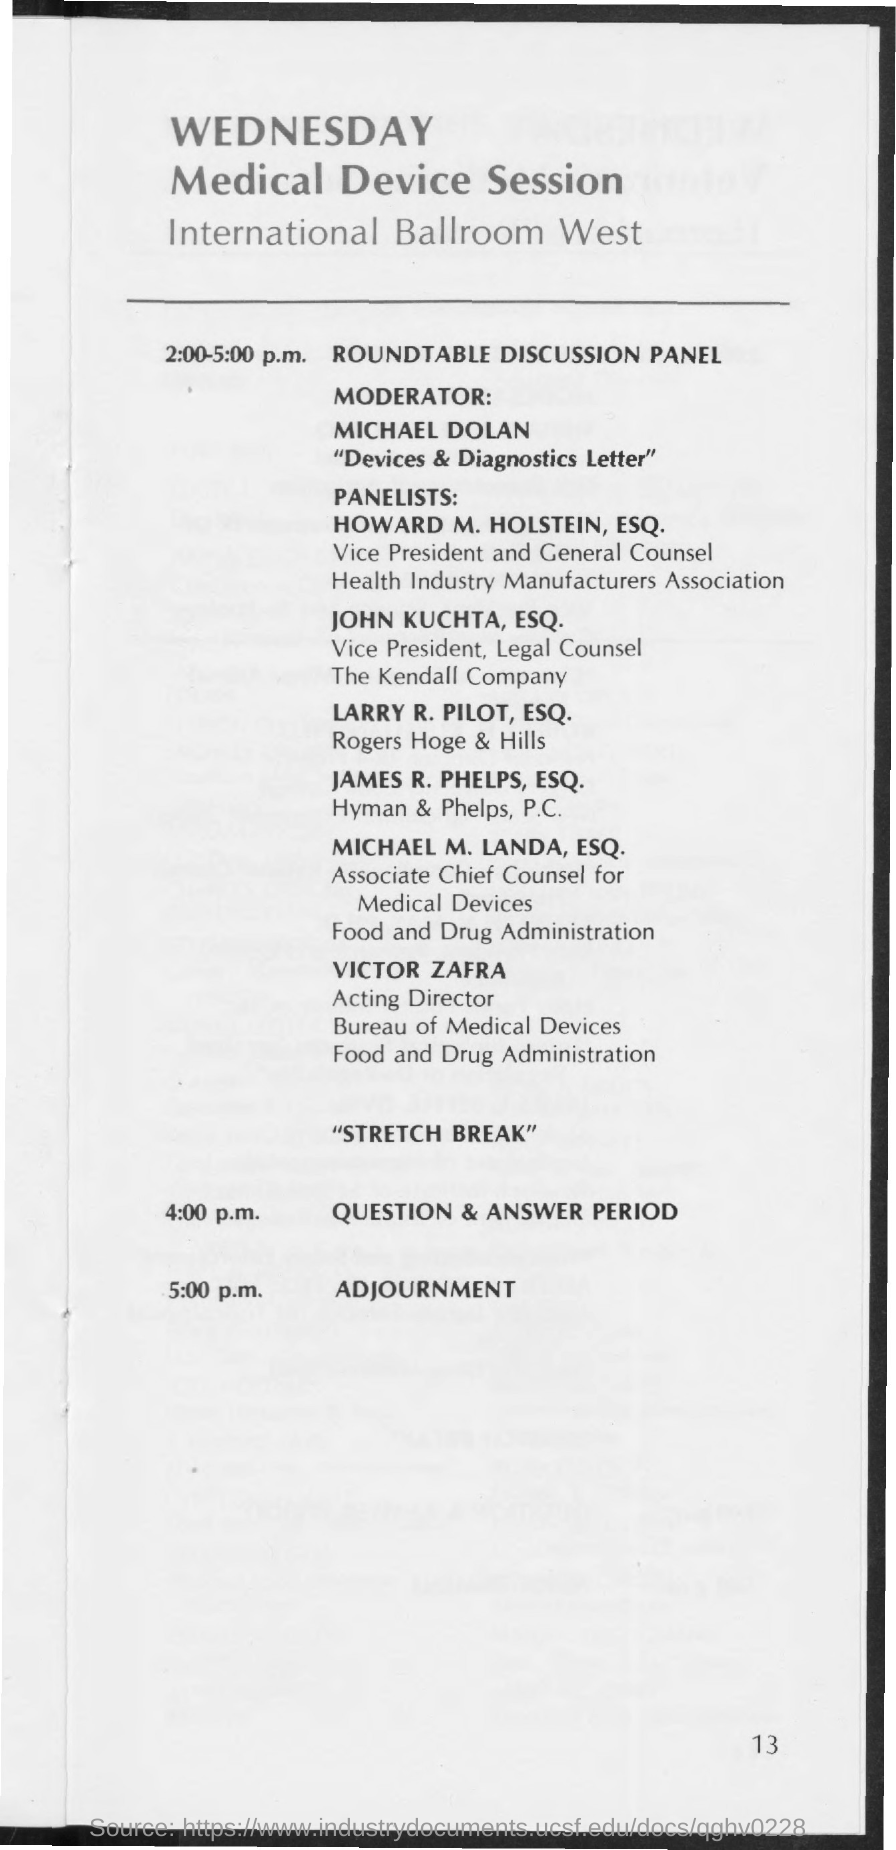Who is the moderator for roundtable discussion Panel?
Provide a short and direct response. Michael Dolan. When is the roundtable discussion Panel?
Make the answer very short. 2:00-5:00 P.M. When is the Question & Answer Period?
Give a very brief answer. 4:00 p.m. When is the Adjournment?
Provide a short and direct response. 5:00 p.m. 